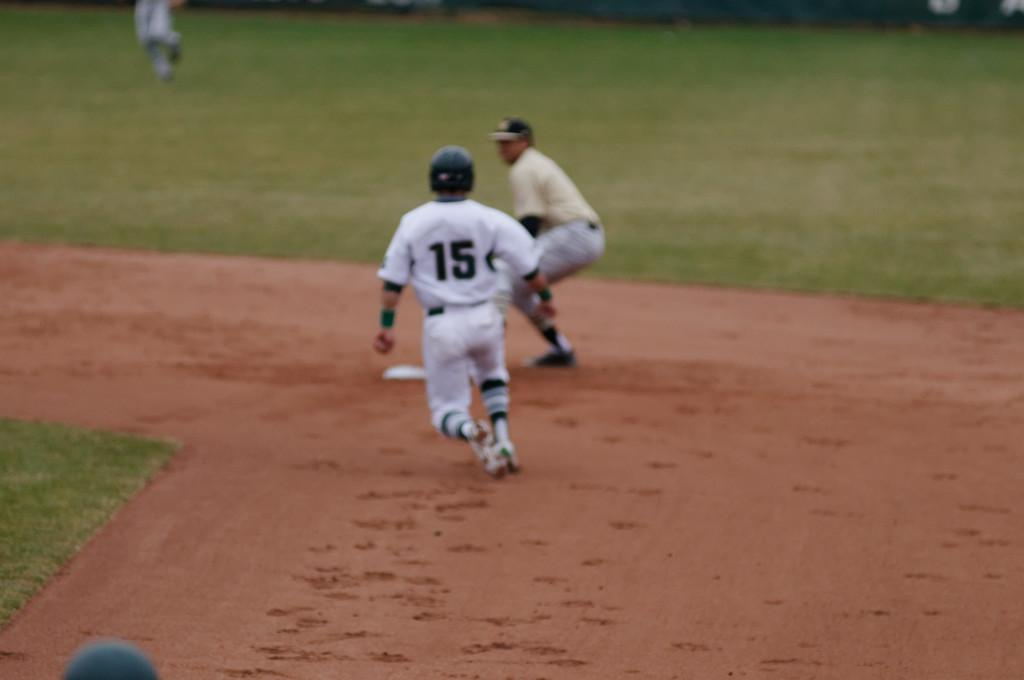<image>
Offer a succinct explanation of the picture presented. A baseball player wearing jersey number 15 is stealing a base. 